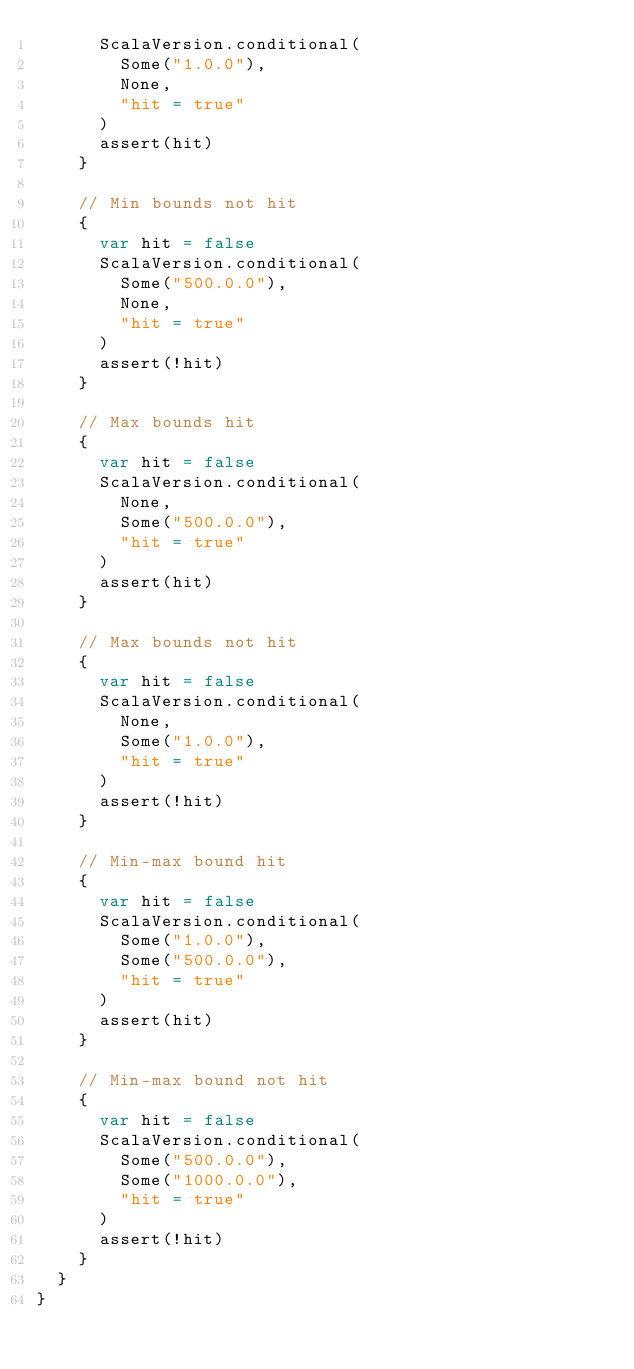<code> <loc_0><loc_0><loc_500><loc_500><_Scala_>      ScalaVersion.conditional(
        Some("1.0.0"),
        None,
        "hit = true"
      )
      assert(hit)
    }

    // Min bounds not hit
    {
      var hit = false
      ScalaVersion.conditional(
        Some("500.0.0"),
        None,
        "hit = true"
      )
      assert(!hit)
    }

    // Max bounds hit
    {
      var hit = false
      ScalaVersion.conditional(
        None,
        Some("500.0.0"),
        "hit = true"
      )
      assert(hit)
    }

    // Max bounds not hit
    {
      var hit = false
      ScalaVersion.conditional(
        None,
        Some("1.0.0"),
        "hit = true"
      )
      assert(!hit)
    }

    // Min-max bound hit
    {
      var hit = false
      ScalaVersion.conditional(
        Some("1.0.0"),
        Some("500.0.0"),
        "hit = true"
      )
      assert(hit)
    }

    // Min-max bound not hit
    {
      var hit = false
      ScalaVersion.conditional(
        Some("500.0.0"),
        Some("1000.0.0"),
        "hit = true"
      )
      assert(!hit)
    }
  }
}
</code> 